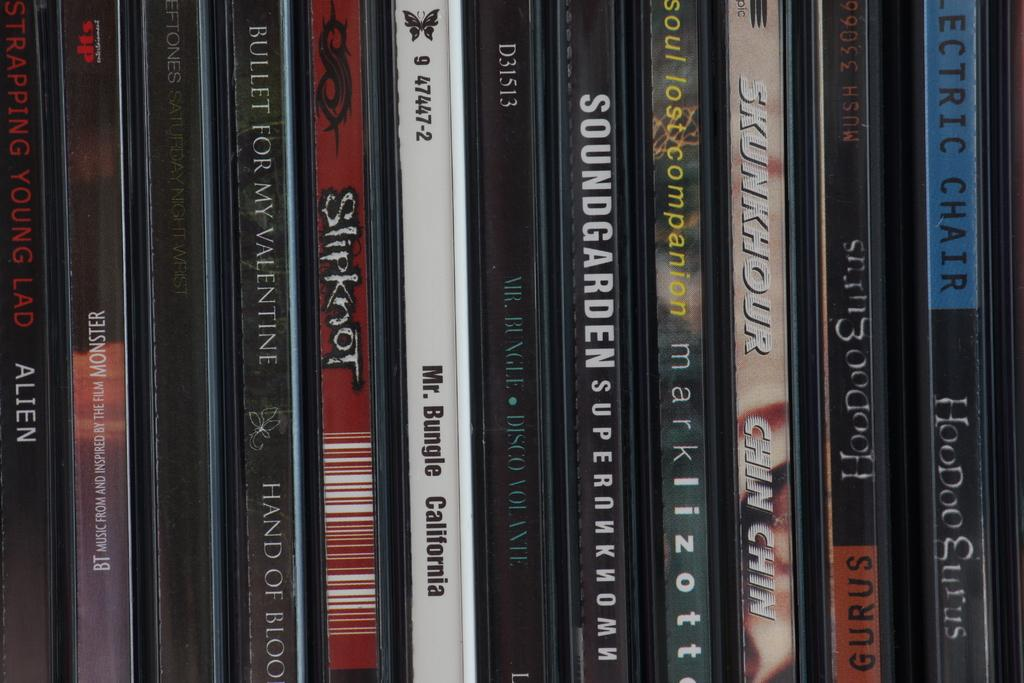<image>
Relay a brief, clear account of the picture shown. A shelf lined with various DVD's with one being Slipknot. 